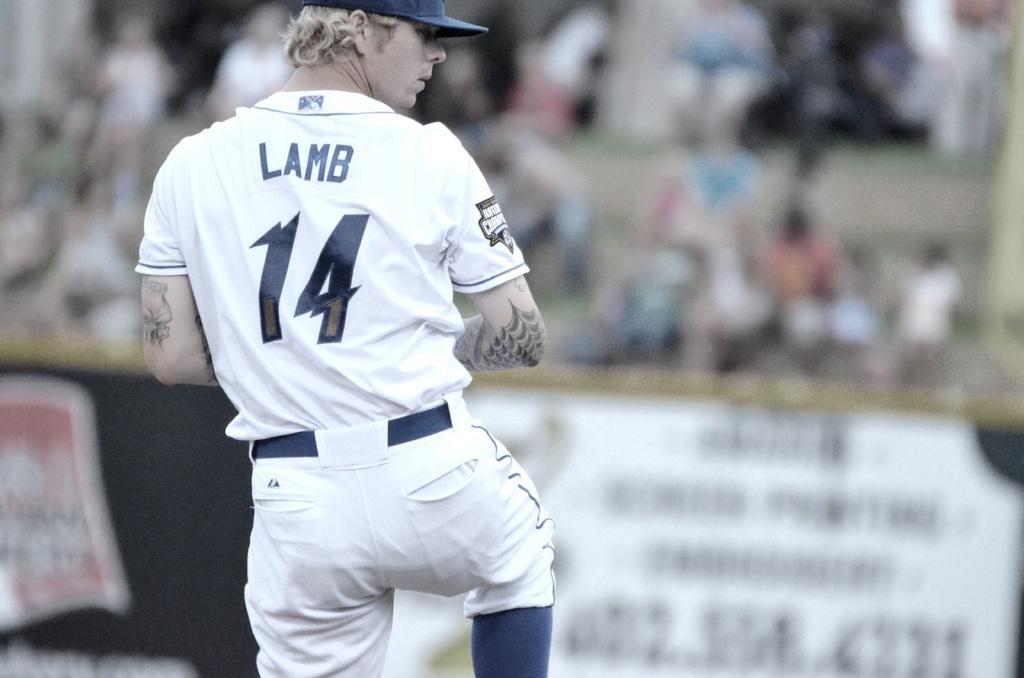<image>
Share a concise interpretation of the image provided. a baseball player wearing the number '14' uniform 